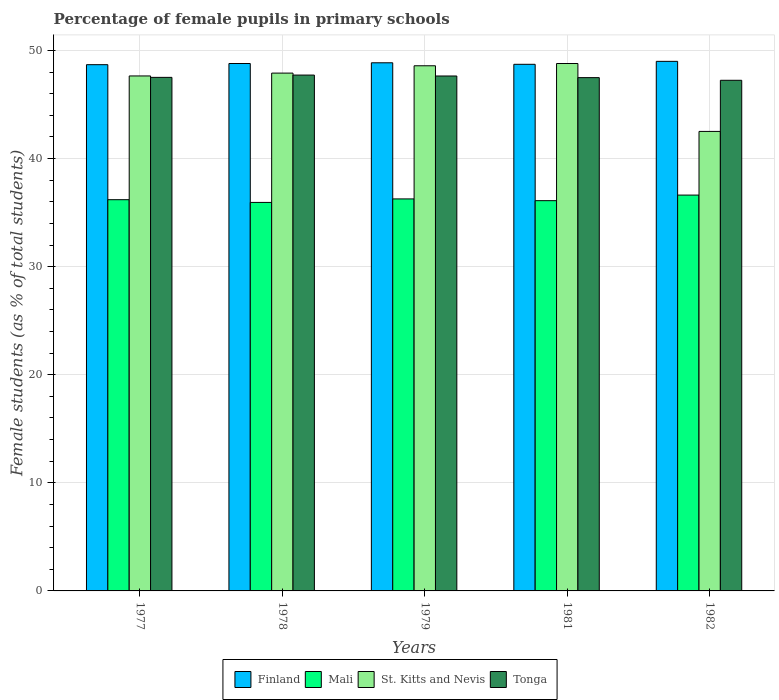How many groups of bars are there?
Keep it short and to the point. 5. Are the number of bars per tick equal to the number of legend labels?
Keep it short and to the point. Yes. Are the number of bars on each tick of the X-axis equal?
Provide a short and direct response. Yes. How many bars are there on the 5th tick from the left?
Offer a terse response. 4. What is the label of the 4th group of bars from the left?
Your answer should be very brief. 1981. What is the percentage of female pupils in primary schools in St. Kitts and Nevis in 1982?
Provide a short and direct response. 42.51. Across all years, what is the maximum percentage of female pupils in primary schools in Finland?
Keep it short and to the point. 48.99. Across all years, what is the minimum percentage of female pupils in primary schools in Tonga?
Your answer should be compact. 47.24. In which year was the percentage of female pupils in primary schools in St. Kitts and Nevis minimum?
Your answer should be very brief. 1982. What is the total percentage of female pupils in primary schools in Finland in the graph?
Offer a terse response. 244.03. What is the difference between the percentage of female pupils in primary schools in Finland in 1979 and that in 1982?
Ensure brevity in your answer.  -0.13. What is the difference between the percentage of female pupils in primary schools in Tonga in 1982 and the percentage of female pupils in primary schools in Mali in 1978?
Provide a succinct answer. 11.3. What is the average percentage of female pupils in primary schools in Mali per year?
Provide a short and direct response. 36.22. In the year 1979, what is the difference between the percentage of female pupils in primary schools in St. Kitts and Nevis and percentage of female pupils in primary schools in Tonga?
Give a very brief answer. 0.95. In how many years, is the percentage of female pupils in primary schools in Mali greater than 16 %?
Make the answer very short. 5. What is the ratio of the percentage of female pupils in primary schools in Tonga in 1979 to that in 1981?
Your response must be concise. 1. Is the percentage of female pupils in primary schools in St. Kitts and Nevis in 1978 less than that in 1981?
Offer a very short reply. Yes. Is the difference between the percentage of female pupils in primary schools in St. Kitts and Nevis in 1979 and 1982 greater than the difference between the percentage of female pupils in primary schools in Tonga in 1979 and 1982?
Ensure brevity in your answer.  Yes. What is the difference between the highest and the second highest percentage of female pupils in primary schools in Finland?
Your response must be concise. 0.13. What is the difference between the highest and the lowest percentage of female pupils in primary schools in Tonga?
Provide a succinct answer. 0.48. In how many years, is the percentage of female pupils in primary schools in Mali greater than the average percentage of female pupils in primary schools in Mali taken over all years?
Keep it short and to the point. 2. Is the sum of the percentage of female pupils in primary schools in Tonga in 1977 and 1982 greater than the maximum percentage of female pupils in primary schools in Finland across all years?
Offer a very short reply. Yes. Is it the case that in every year, the sum of the percentage of female pupils in primary schools in Finland and percentage of female pupils in primary schools in Mali is greater than the sum of percentage of female pupils in primary schools in St. Kitts and Nevis and percentage of female pupils in primary schools in Tonga?
Your answer should be compact. No. What does the 3rd bar from the right in 1982 represents?
Offer a very short reply. Mali. How many years are there in the graph?
Offer a very short reply. 5. What is the difference between two consecutive major ticks on the Y-axis?
Offer a very short reply. 10. Does the graph contain any zero values?
Offer a very short reply. No. Where does the legend appear in the graph?
Keep it short and to the point. Bottom center. How many legend labels are there?
Give a very brief answer. 4. What is the title of the graph?
Offer a very short reply. Percentage of female pupils in primary schools. Does "Gambia, The" appear as one of the legend labels in the graph?
Keep it short and to the point. No. What is the label or title of the X-axis?
Your response must be concise. Years. What is the label or title of the Y-axis?
Make the answer very short. Female students (as % of total students). What is the Female students (as % of total students) in Finland in 1977?
Provide a succinct answer. 48.68. What is the Female students (as % of total students) of Mali in 1977?
Provide a succinct answer. 36.19. What is the Female students (as % of total students) of St. Kitts and Nevis in 1977?
Provide a short and direct response. 47.64. What is the Female students (as % of total students) in Tonga in 1977?
Offer a terse response. 47.51. What is the Female students (as % of total students) of Finland in 1978?
Your response must be concise. 48.79. What is the Female students (as % of total students) of Mali in 1978?
Your answer should be compact. 35.94. What is the Female students (as % of total students) in St. Kitts and Nevis in 1978?
Provide a succinct answer. 47.9. What is the Female students (as % of total students) in Tonga in 1978?
Keep it short and to the point. 47.72. What is the Female students (as % of total students) of Finland in 1979?
Your response must be concise. 48.86. What is the Female students (as % of total students) in Mali in 1979?
Keep it short and to the point. 36.26. What is the Female students (as % of total students) in St. Kitts and Nevis in 1979?
Your answer should be compact. 48.58. What is the Female students (as % of total students) of Tonga in 1979?
Offer a terse response. 47.63. What is the Female students (as % of total students) of Finland in 1981?
Provide a succinct answer. 48.72. What is the Female students (as % of total students) in Mali in 1981?
Provide a short and direct response. 36.1. What is the Female students (as % of total students) of St. Kitts and Nevis in 1981?
Your answer should be very brief. 48.79. What is the Female students (as % of total students) of Tonga in 1981?
Offer a very short reply. 47.48. What is the Female students (as % of total students) of Finland in 1982?
Ensure brevity in your answer.  48.99. What is the Female students (as % of total students) in Mali in 1982?
Ensure brevity in your answer.  36.62. What is the Female students (as % of total students) of St. Kitts and Nevis in 1982?
Your answer should be compact. 42.51. What is the Female students (as % of total students) in Tonga in 1982?
Provide a succinct answer. 47.24. Across all years, what is the maximum Female students (as % of total students) of Finland?
Your answer should be very brief. 48.99. Across all years, what is the maximum Female students (as % of total students) in Mali?
Make the answer very short. 36.62. Across all years, what is the maximum Female students (as % of total students) in St. Kitts and Nevis?
Make the answer very short. 48.79. Across all years, what is the maximum Female students (as % of total students) in Tonga?
Offer a very short reply. 47.72. Across all years, what is the minimum Female students (as % of total students) of Finland?
Offer a terse response. 48.68. Across all years, what is the minimum Female students (as % of total students) of Mali?
Your answer should be compact. 35.94. Across all years, what is the minimum Female students (as % of total students) in St. Kitts and Nevis?
Provide a short and direct response. 42.51. Across all years, what is the minimum Female students (as % of total students) of Tonga?
Provide a short and direct response. 47.24. What is the total Female students (as % of total students) in Finland in the graph?
Make the answer very short. 244.03. What is the total Female students (as % of total students) of Mali in the graph?
Provide a short and direct response. 181.11. What is the total Female students (as % of total students) of St. Kitts and Nevis in the graph?
Provide a short and direct response. 235.42. What is the total Female students (as % of total students) in Tonga in the graph?
Your answer should be very brief. 237.58. What is the difference between the Female students (as % of total students) in Finland in 1977 and that in 1978?
Your answer should be compact. -0.11. What is the difference between the Female students (as % of total students) in Mali in 1977 and that in 1978?
Your response must be concise. 0.25. What is the difference between the Female students (as % of total students) of St. Kitts and Nevis in 1977 and that in 1978?
Keep it short and to the point. -0.26. What is the difference between the Female students (as % of total students) in Tonga in 1977 and that in 1978?
Ensure brevity in your answer.  -0.21. What is the difference between the Female students (as % of total students) in Finland in 1977 and that in 1979?
Provide a succinct answer. -0.17. What is the difference between the Female students (as % of total students) in Mali in 1977 and that in 1979?
Offer a very short reply. -0.07. What is the difference between the Female students (as % of total students) of St. Kitts and Nevis in 1977 and that in 1979?
Make the answer very short. -0.94. What is the difference between the Female students (as % of total students) in Tonga in 1977 and that in 1979?
Keep it short and to the point. -0.13. What is the difference between the Female students (as % of total students) of Finland in 1977 and that in 1981?
Your answer should be compact. -0.03. What is the difference between the Female students (as % of total students) of Mali in 1977 and that in 1981?
Keep it short and to the point. 0.09. What is the difference between the Female students (as % of total students) of St. Kitts and Nevis in 1977 and that in 1981?
Your response must be concise. -1.15. What is the difference between the Female students (as % of total students) of Tonga in 1977 and that in 1981?
Offer a very short reply. 0.02. What is the difference between the Female students (as % of total students) of Finland in 1977 and that in 1982?
Your answer should be very brief. -0.31. What is the difference between the Female students (as % of total students) in Mali in 1977 and that in 1982?
Keep it short and to the point. -0.43. What is the difference between the Female students (as % of total students) of St. Kitts and Nevis in 1977 and that in 1982?
Ensure brevity in your answer.  5.13. What is the difference between the Female students (as % of total students) of Tonga in 1977 and that in 1982?
Make the answer very short. 0.27. What is the difference between the Female students (as % of total students) in Finland in 1978 and that in 1979?
Provide a succinct answer. -0.07. What is the difference between the Female students (as % of total students) in Mali in 1978 and that in 1979?
Ensure brevity in your answer.  -0.32. What is the difference between the Female students (as % of total students) in St. Kitts and Nevis in 1978 and that in 1979?
Keep it short and to the point. -0.68. What is the difference between the Female students (as % of total students) in Tonga in 1978 and that in 1979?
Keep it short and to the point. 0.08. What is the difference between the Female students (as % of total students) in Finland in 1978 and that in 1981?
Offer a very short reply. 0.07. What is the difference between the Female students (as % of total students) in Mali in 1978 and that in 1981?
Your response must be concise. -0.16. What is the difference between the Female students (as % of total students) in St. Kitts and Nevis in 1978 and that in 1981?
Your answer should be compact. -0.89. What is the difference between the Female students (as % of total students) in Tonga in 1978 and that in 1981?
Keep it short and to the point. 0.24. What is the difference between the Female students (as % of total students) of Finland in 1978 and that in 1982?
Your answer should be very brief. -0.2. What is the difference between the Female students (as % of total students) of Mali in 1978 and that in 1982?
Give a very brief answer. -0.68. What is the difference between the Female students (as % of total students) of St. Kitts and Nevis in 1978 and that in 1982?
Provide a succinct answer. 5.39. What is the difference between the Female students (as % of total students) of Tonga in 1978 and that in 1982?
Keep it short and to the point. 0.48. What is the difference between the Female students (as % of total students) of Finland in 1979 and that in 1981?
Your response must be concise. 0.14. What is the difference between the Female students (as % of total students) in Mali in 1979 and that in 1981?
Make the answer very short. 0.16. What is the difference between the Female students (as % of total students) in St. Kitts and Nevis in 1979 and that in 1981?
Your answer should be very brief. -0.21. What is the difference between the Female students (as % of total students) in Tonga in 1979 and that in 1981?
Provide a short and direct response. 0.15. What is the difference between the Female students (as % of total students) in Finland in 1979 and that in 1982?
Make the answer very short. -0.13. What is the difference between the Female students (as % of total students) of Mali in 1979 and that in 1982?
Give a very brief answer. -0.35. What is the difference between the Female students (as % of total students) in St. Kitts and Nevis in 1979 and that in 1982?
Ensure brevity in your answer.  6.07. What is the difference between the Female students (as % of total students) of Tonga in 1979 and that in 1982?
Give a very brief answer. 0.4. What is the difference between the Female students (as % of total students) of Finland in 1981 and that in 1982?
Ensure brevity in your answer.  -0.27. What is the difference between the Female students (as % of total students) in Mali in 1981 and that in 1982?
Your response must be concise. -0.52. What is the difference between the Female students (as % of total students) of St. Kitts and Nevis in 1981 and that in 1982?
Offer a very short reply. 6.28. What is the difference between the Female students (as % of total students) of Tonga in 1981 and that in 1982?
Your answer should be compact. 0.25. What is the difference between the Female students (as % of total students) of Finland in 1977 and the Female students (as % of total students) of Mali in 1978?
Ensure brevity in your answer.  12.74. What is the difference between the Female students (as % of total students) of Finland in 1977 and the Female students (as % of total students) of St. Kitts and Nevis in 1978?
Your response must be concise. 0.78. What is the difference between the Female students (as % of total students) of Mali in 1977 and the Female students (as % of total students) of St. Kitts and Nevis in 1978?
Make the answer very short. -11.71. What is the difference between the Female students (as % of total students) in Mali in 1977 and the Female students (as % of total students) in Tonga in 1978?
Make the answer very short. -11.53. What is the difference between the Female students (as % of total students) in St. Kitts and Nevis in 1977 and the Female students (as % of total students) in Tonga in 1978?
Your response must be concise. -0.08. What is the difference between the Female students (as % of total students) of Finland in 1977 and the Female students (as % of total students) of Mali in 1979?
Offer a terse response. 12.42. What is the difference between the Female students (as % of total students) in Finland in 1977 and the Female students (as % of total students) in St. Kitts and Nevis in 1979?
Provide a succinct answer. 0.1. What is the difference between the Female students (as % of total students) in Finland in 1977 and the Female students (as % of total students) in Tonga in 1979?
Give a very brief answer. 1.05. What is the difference between the Female students (as % of total students) in Mali in 1977 and the Female students (as % of total students) in St. Kitts and Nevis in 1979?
Your response must be concise. -12.39. What is the difference between the Female students (as % of total students) in Mali in 1977 and the Female students (as % of total students) in Tonga in 1979?
Provide a short and direct response. -11.44. What is the difference between the Female students (as % of total students) in St. Kitts and Nevis in 1977 and the Female students (as % of total students) in Tonga in 1979?
Your response must be concise. 0. What is the difference between the Female students (as % of total students) in Finland in 1977 and the Female students (as % of total students) in Mali in 1981?
Your answer should be very brief. 12.58. What is the difference between the Female students (as % of total students) of Finland in 1977 and the Female students (as % of total students) of St. Kitts and Nevis in 1981?
Your answer should be compact. -0.11. What is the difference between the Female students (as % of total students) of Finland in 1977 and the Female students (as % of total students) of Tonga in 1981?
Your answer should be very brief. 1.2. What is the difference between the Female students (as % of total students) in Mali in 1977 and the Female students (as % of total students) in St. Kitts and Nevis in 1981?
Your answer should be compact. -12.6. What is the difference between the Female students (as % of total students) in Mali in 1977 and the Female students (as % of total students) in Tonga in 1981?
Provide a short and direct response. -11.29. What is the difference between the Female students (as % of total students) in St. Kitts and Nevis in 1977 and the Female students (as % of total students) in Tonga in 1981?
Offer a very short reply. 0.16. What is the difference between the Female students (as % of total students) in Finland in 1977 and the Female students (as % of total students) in Mali in 1982?
Offer a terse response. 12.06. What is the difference between the Female students (as % of total students) of Finland in 1977 and the Female students (as % of total students) of St. Kitts and Nevis in 1982?
Ensure brevity in your answer.  6.17. What is the difference between the Female students (as % of total students) of Finland in 1977 and the Female students (as % of total students) of Tonga in 1982?
Give a very brief answer. 1.44. What is the difference between the Female students (as % of total students) of Mali in 1977 and the Female students (as % of total students) of St. Kitts and Nevis in 1982?
Offer a very short reply. -6.32. What is the difference between the Female students (as % of total students) in Mali in 1977 and the Female students (as % of total students) in Tonga in 1982?
Keep it short and to the point. -11.05. What is the difference between the Female students (as % of total students) in St. Kitts and Nevis in 1977 and the Female students (as % of total students) in Tonga in 1982?
Provide a short and direct response. 0.4. What is the difference between the Female students (as % of total students) of Finland in 1978 and the Female students (as % of total students) of Mali in 1979?
Keep it short and to the point. 12.53. What is the difference between the Female students (as % of total students) in Finland in 1978 and the Female students (as % of total students) in St. Kitts and Nevis in 1979?
Your response must be concise. 0.21. What is the difference between the Female students (as % of total students) of Finland in 1978 and the Female students (as % of total students) of Tonga in 1979?
Your answer should be very brief. 1.15. What is the difference between the Female students (as % of total students) in Mali in 1978 and the Female students (as % of total students) in St. Kitts and Nevis in 1979?
Keep it short and to the point. -12.64. What is the difference between the Female students (as % of total students) of Mali in 1978 and the Female students (as % of total students) of Tonga in 1979?
Your response must be concise. -11.7. What is the difference between the Female students (as % of total students) in St. Kitts and Nevis in 1978 and the Female students (as % of total students) in Tonga in 1979?
Your answer should be compact. 0.27. What is the difference between the Female students (as % of total students) in Finland in 1978 and the Female students (as % of total students) in Mali in 1981?
Your answer should be compact. 12.69. What is the difference between the Female students (as % of total students) in Finland in 1978 and the Female students (as % of total students) in St. Kitts and Nevis in 1981?
Your answer should be very brief. -0. What is the difference between the Female students (as % of total students) in Finland in 1978 and the Female students (as % of total students) in Tonga in 1981?
Give a very brief answer. 1.31. What is the difference between the Female students (as % of total students) in Mali in 1978 and the Female students (as % of total students) in St. Kitts and Nevis in 1981?
Your response must be concise. -12.85. What is the difference between the Female students (as % of total students) of Mali in 1978 and the Female students (as % of total students) of Tonga in 1981?
Your answer should be compact. -11.54. What is the difference between the Female students (as % of total students) of St. Kitts and Nevis in 1978 and the Female students (as % of total students) of Tonga in 1981?
Your response must be concise. 0.42. What is the difference between the Female students (as % of total students) in Finland in 1978 and the Female students (as % of total students) in Mali in 1982?
Your answer should be very brief. 12.17. What is the difference between the Female students (as % of total students) in Finland in 1978 and the Female students (as % of total students) in St. Kitts and Nevis in 1982?
Keep it short and to the point. 6.28. What is the difference between the Female students (as % of total students) of Finland in 1978 and the Female students (as % of total students) of Tonga in 1982?
Offer a very short reply. 1.55. What is the difference between the Female students (as % of total students) of Mali in 1978 and the Female students (as % of total students) of St. Kitts and Nevis in 1982?
Provide a succinct answer. -6.57. What is the difference between the Female students (as % of total students) in Mali in 1978 and the Female students (as % of total students) in Tonga in 1982?
Ensure brevity in your answer.  -11.3. What is the difference between the Female students (as % of total students) of St. Kitts and Nevis in 1978 and the Female students (as % of total students) of Tonga in 1982?
Make the answer very short. 0.67. What is the difference between the Female students (as % of total students) in Finland in 1979 and the Female students (as % of total students) in Mali in 1981?
Offer a terse response. 12.75. What is the difference between the Female students (as % of total students) in Finland in 1979 and the Female students (as % of total students) in St. Kitts and Nevis in 1981?
Provide a short and direct response. 0.07. What is the difference between the Female students (as % of total students) of Finland in 1979 and the Female students (as % of total students) of Tonga in 1981?
Your answer should be compact. 1.37. What is the difference between the Female students (as % of total students) in Mali in 1979 and the Female students (as % of total students) in St. Kitts and Nevis in 1981?
Offer a terse response. -12.53. What is the difference between the Female students (as % of total students) of Mali in 1979 and the Female students (as % of total students) of Tonga in 1981?
Your answer should be compact. -11.22. What is the difference between the Female students (as % of total students) of St. Kitts and Nevis in 1979 and the Female students (as % of total students) of Tonga in 1981?
Provide a short and direct response. 1.1. What is the difference between the Female students (as % of total students) in Finland in 1979 and the Female students (as % of total students) in Mali in 1982?
Offer a terse response. 12.24. What is the difference between the Female students (as % of total students) of Finland in 1979 and the Female students (as % of total students) of St. Kitts and Nevis in 1982?
Provide a succinct answer. 6.35. What is the difference between the Female students (as % of total students) in Finland in 1979 and the Female students (as % of total students) in Tonga in 1982?
Keep it short and to the point. 1.62. What is the difference between the Female students (as % of total students) of Mali in 1979 and the Female students (as % of total students) of St. Kitts and Nevis in 1982?
Your answer should be very brief. -6.24. What is the difference between the Female students (as % of total students) in Mali in 1979 and the Female students (as % of total students) in Tonga in 1982?
Make the answer very short. -10.97. What is the difference between the Female students (as % of total students) of St. Kitts and Nevis in 1979 and the Female students (as % of total students) of Tonga in 1982?
Provide a succinct answer. 1.34. What is the difference between the Female students (as % of total students) in Finland in 1981 and the Female students (as % of total students) in Mali in 1982?
Provide a short and direct response. 12.1. What is the difference between the Female students (as % of total students) of Finland in 1981 and the Female students (as % of total students) of St. Kitts and Nevis in 1982?
Your response must be concise. 6.21. What is the difference between the Female students (as % of total students) of Finland in 1981 and the Female students (as % of total students) of Tonga in 1982?
Keep it short and to the point. 1.48. What is the difference between the Female students (as % of total students) in Mali in 1981 and the Female students (as % of total students) in St. Kitts and Nevis in 1982?
Keep it short and to the point. -6.41. What is the difference between the Female students (as % of total students) of Mali in 1981 and the Female students (as % of total students) of Tonga in 1982?
Your answer should be very brief. -11.13. What is the difference between the Female students (as % of total students) of St. Kitts and Nevis in 1981 and the Female students (as % of total students) of Tonga in 1982?
Keep it short and to the point. 1.55. What is the average Female students (as % of total students) in Finland per year?
Give a very brief answer. 48.81. What is the average Female students (as % of total students) of Mali per year?
Your answer should be very brief. 36.22. What is the average Female students (as % of total students) in St. Kitts and Nevis per year?
Keep it short and to the point. 47.08. What is the average Female students (as % of total students) in Tonga per year?
Ensure brevity in your answer.  47.52. In the year 1977, what is the difference between the Female students (as % of total students) of Finland and Female students (as % of total students) of Mali?
Provide a short and direct response. 12.49. In the year 1977, what is the difference between the Female students (as % of total students) in Finland and Female students (as % of total students) in St. Kitts and Nevis?
Your response must be concise. 1.04. In the year 1977, what is the difference between the Female students (as % of total students) of Finland and Female students (as % of total students) of Tonga?
Provide a succinct answer. 1.17. In the year 1977, what is the difference between the Female students (as % of total students) in Mali and Female students (as % of total students) in St. Kitts and Nevis?
Offer a terse response. -11.45. In the year 1977, what is the difference between the Female students (as % of total students) in Mali and Female students (as % of total students) in Tonga?
Provide a succinct answer. -11.32. In the year 1977, what is the difference between the Female students (as % of total students) of St. Kitts and Nevis and Female students (as % of total students) of Tonga?
Your response must be concise. 0.13. In the year 1978, what is the difference between the Female students (as % of total students) in Finland and Female students (as % of total students) in Mali?
Your response must be concise. 12.85. In the year 1978, what is the difference between the Female students (as % of total students) in Finland and Female students (as % of total students) in St. Kitts and Nevis?
Keep it short and to the point. 0.89. In the year 1978, what is the difference between the Female students (as % of total students) in Finland and Female students (as % of total students) in Tonga?
Your answer should be compact. 1.07. In the year 1978, what is the difference between the Female students (as % of total students) of Mali and Female students (as % of total students) of St. Kitts and Nevis?
Provide a short and direct response. -11.96. In the year 1978, what is the difference between the Female students (as % of total students) of Mali and Female students (as % of total students) of Tonga?
Give a very brief answer. -11.78. In the year 1978, what is the difference between the Female students (as % of total students) of St. Kitts and Nevis and Female students (as % of total students) of Tonga?
Keep it short and to the point. 0.18. In the year 1979, what is the difference between the Female students (as % of total students) of Finland and Female students (as % of total students) of Mali?
Provide a short and direct response. 12.59. In the year 1979, what is the difference between the Female students (as % of total students) in Finland and Female students (as % of total students) in St. Kitts and Nevis?
Keep it short and to the point. 0.28. In the year 1979, what is the difference between the Female students (as % of total students) in Finland and Female students (as % of total students) in Tonga?
Your answer should be compact. 1.22. In the year 1979, what is the difference between the Female students (as % of total students) of Mali and Female students (as % of total students) of St. Kitts and Nevis?
Your answer should be compact. -12.32. In the year 1979, what is the difference between the Female students (as % of total students) in Mali and Female students (as % of total students) in Tonga?
Make the answer very short. -11.37. In the year 1979, what is the difference between the Female students (as % of total students) of St. Kitts and Nevis and Female students (as % of total students) of Tonga?
Your response must be concise. 0.95. In the year 1981, what is the difference between the Female students (as % of total students) in Finland and Female students (as % of total students) in Mali?
Offer a very short reply. 12.61. In the year 1981, what is the difference between the Female students (as % of total students) in Finland and Female students (as % of total students) in St. Kitts and Nevis?
Give a very brief answer. -0.07. In the year 1981, what is the difference between the Female students (as % of total students) of Finland and Female students (as % of total students) of Tonga?
Make the answer very short. 1.23. In the year 1981, what is the difference between the Female students (as % of total students) of Mali and Female students (as % of total students) of St. Kitts and Nevis?
Give a very brief answer. -12.69. In the year 1981, what is the difference between the Female students (as % of total students) in Mali and Female students (as % of total students) in Tonga?
Offer a very short reply. -11.38. In the year 1981, what is the difference between the Female students (as % of total students) of St. Kitts and Nevis and Female students (as % of total students) of Tonga?
Keep it short and to the point. 1.31. In the year 1982, what is the difference between the Female students (as % of total students) in Finland and Female students (as % of total students) in Mali?
Give a very brief answer. 12.37. In the year 1982, what is the difference between the Female students (as % of total students) in Finland and Female students (as % of total students) in St. Kitts and Nevis?
Keep it short and to the point. 6.48. In the year 1982, what is the difference between the Female students (as % of total students) of Finland and Female students (as % of total students) of Tonga?
Give a very brief answer. 1.75. In the year 1982, what is the difference between the Female students (as % of total students) in Mali and Female students (as % of total students) in St. Kitts and Nevis?
Provide a succinct answer. -5.89. In the year 1982, what is the difference between the Female students (as % of total students) of Mali and Female students (as % of total students) of Tonga?
Your answer should be very brief. -10.62. In the year 1982, what is the difference between the Female students (as % of total students) in St. Kitts and Nevis and Female students (as % of total students) in Tonga?
Provide a succinct answer. -4.73. What is the ratio of the Female students (as % of total students) in Finland in 1977 to that in 1978?
Make the answer very short. 1. What is the ratio of the Female students (as % of total students) of Finland in 1977 to that in 1979?
Offer a very short reply. 1. What is the ratio of the Female students (as % of total students) of Mali in 1977 to that in 1979?
Provide a short and direct response. 1. What is the ratio of the Female students (as % of total students) in St. Kitts and Nevis in 1977 to that in 1979?
Provide a succinct answer. 0.98. What is the ratio of the Female students (as % of total students) in Tonga in 1977 to that in 1979?
Your answer should be compact. 1. What is the ratio of the Female students (as % of total students) in St. Kitts and Nevis in 1977 to that in 1981?
Offer a terse response. 0.98. What is the ratio of the Female students (as % of total students) of Tonga in 1977 to that in 1981?
Ensure brevity in your answer.  1. What is the ratio of the Female students (as % of total students) of Finland in 1977 to that in 1982?
Your response must be concise. 0.99. What is the ratio of the Female students (as % of total students) of Mali in 1977 to that in 1982?
Offer a very short reply. 0.99. What is the ratio of the Female students (as % of total students) of St. Kitts and Nevis in 1977 to that in 1982?
Provide a short and direct response. 1.12. What is the ratio of the Female students (as % of total students) in Finland in 1978 to that in 1979?
Provide a succinct answer. 1. What is the ratio of the Female students (as % of total students) of St. Kitts and Nevis in 1978 to that in 1979?
Your answer should be compact. 0.99. What is the ratio of the Female students (as % of total students) in Tonga in 1978 to that in 1979?
Provide a short and direct response. 1. What is the ratio of the Female students (as % of total students) in St. Kitts and Nevis in 1978 to that in 1981?
Your answer should be very brief. 0.98. What is the ratio of the Female students (as % of total students) in Tonga in 1978 to that in 1981?
Offer a very short reply. 1. What is the ratio of the Female students (as % of total students) in Finland in 1978 to that in 1982?
Make the answer very short. 1. What is the ratio of the Female students (as % of total students) in Mali in 1978 to that in 1982?
Provide a succinct answer. 0.98. What is the ratio of the Female students (as % of total students) in St. Kitts and Nevis in 1978 to that in 1982?
Offer a very short reply. 1.13. What is the ratio of the Female students (as % of total students) of Tonga in 1978 to that in 1982?
Keep it short and to the point. 1.01. What is the ratio of the Female students (as % of total students) of St. Kitts and Nevis in 1979 to that in 1981?
Offer a very short reply. 1. What is the ratio of the Female students (as % of total students) of Mali in 1979 to that in 1982?
Offer a very short reply. 0.99. What is the ratio of the Female students (as % of total students) in St. Kitts and Nevis in 1979 to that in 1982?
Provide a succinct answer. 1.14. What is the ratio of the Female students (as % of total students) in Tonga in 1979 to that in 1982?
Provide a succinct answer. 1.01. What is the ratio of the Female students (as % of total students) in Mali in 1981 to that in 1982?
Your answer should be compact. 0.99. What is the ratio of the Female students (as % of total students) of St. Kitts and Nevis in 1981 to that in 1982?
Your answer should be compact. 1.15. What is the ratio of the Female students (as % of total students) in Tonga in 1981 to that in 1982?
Give a very brief answer. 1.01. What is the difference between the highest and the second highest Female students (as % of total students) of Finland?
Offer a very short reply. 0.13. What is the difference between the highest and the second highest Female students (as % of total students) in Mali?
Keep it short and to the point. 0.35. What is the difference between the highest and the second highest Female students (as % of total students) in St. Kitts and Nevis?
Provide a succinct answer. 0.21. What is the difference between the highest and the second highest Female students (as % of total students) in Tonga?
Offer a very short reply. 0.08. What is the difference between the highest and the lowest Female students (as % of total students) in Finland?
Ensure brevity in your answer.  0.31. What is the difference between the highest and the lowest Female students (as % of total students) of Mali?
Offer a very short reply. 0.68. What is the difference between the highest and the lowest Female students (as % of total students) of St. Kitts and Nevis?
Keep it short and to the point. 6.28. What is the difference between the highest and the lowest Female students (as % of total students) in Tonga?
Keep it short and to the point. 0.48. 